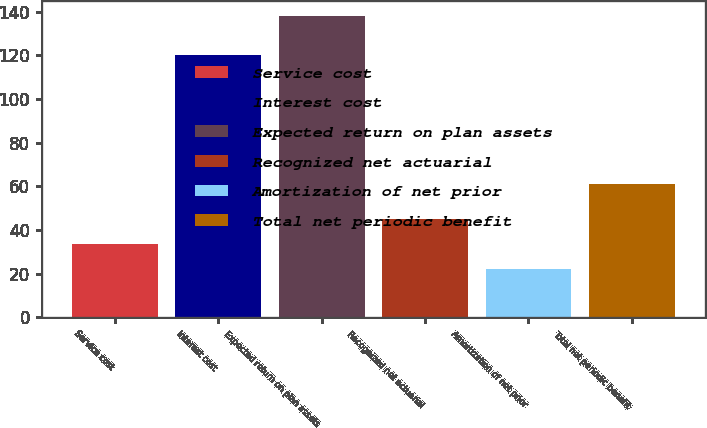<chart> <loc_0><loc_0><loc_500><loc_500><bar_chart><fcel>Service cost<fcel>Interest cost<fcel>Expected return on plan assets<fcel>Recognized net actuarial<fcel>Amortization of net prior<fcel>Total net periodic benefit<nl><fcel>33.6<fcel>120<fcel>138<fcel>45.2<fcel>22<fcel>61<nl></chart> 